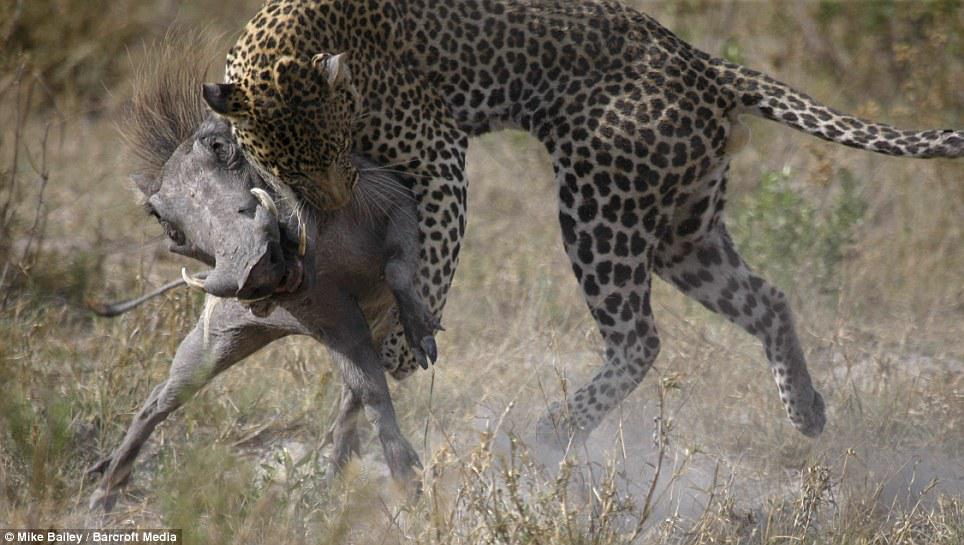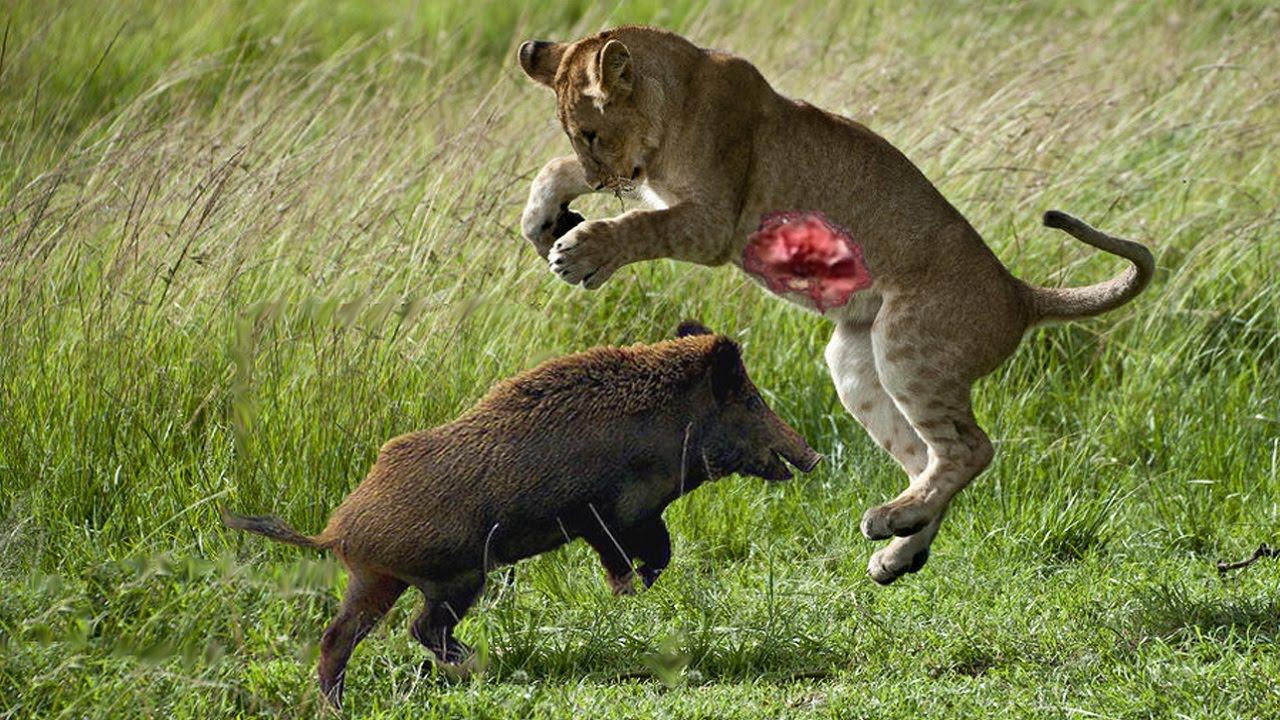The first image is the image on the left, the second image is the image on the right. For the images displayed, is the sentence "a jaguar is attacking a warthog" factually correct? Answer yes or no. Yes. The first image is the image on the left, the second image is the image on the right. Evaluate the accuracy of this statement regarding the images: "A warthog is fighting with a cheetah.". Is it true? Answer yes or no. Yes. 